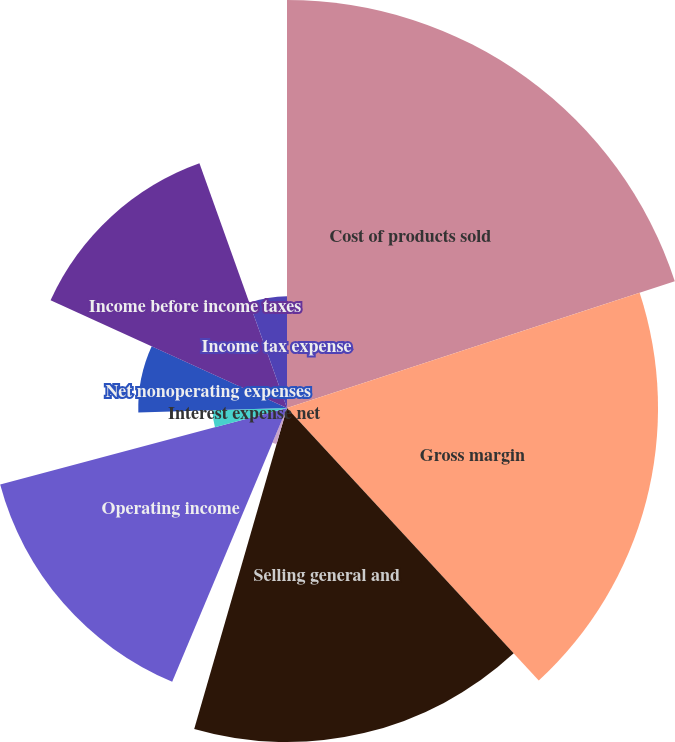Convert chart. <chart><loc_0><loc_0><loc_500><loc_500><pie_chart><fcel>Cost of products sold<fcel>Gross margin<fcel>Selling general and<fcel>Restructuring costs<fcel>Operating income<fcel>Interest expense net<fcel>Losses related to<fcel>Net nonoperating expenses<fcel>Income before income taxes<fcel>Income tax expense<nl><fcel>19.97%<fcel>18.16%<fcel>16.35%<fcel>1.84%<fcel>14.53%<fcel>3.65%<fcel>0.03%<fcel>7.28%<fcel>12.72%<fcel>5.47%<nl></chart> 